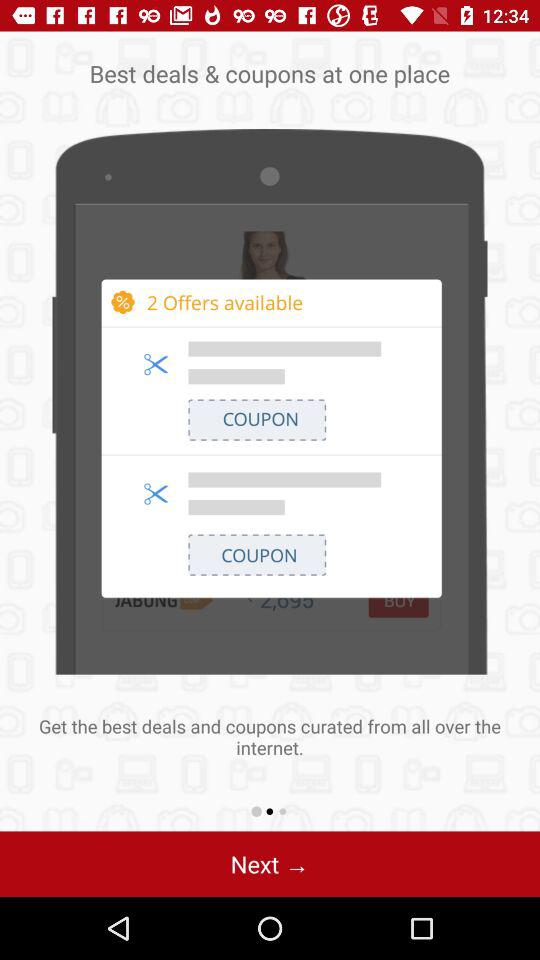How many coupons are available?
Answer the question using a single word or phrase. 2 